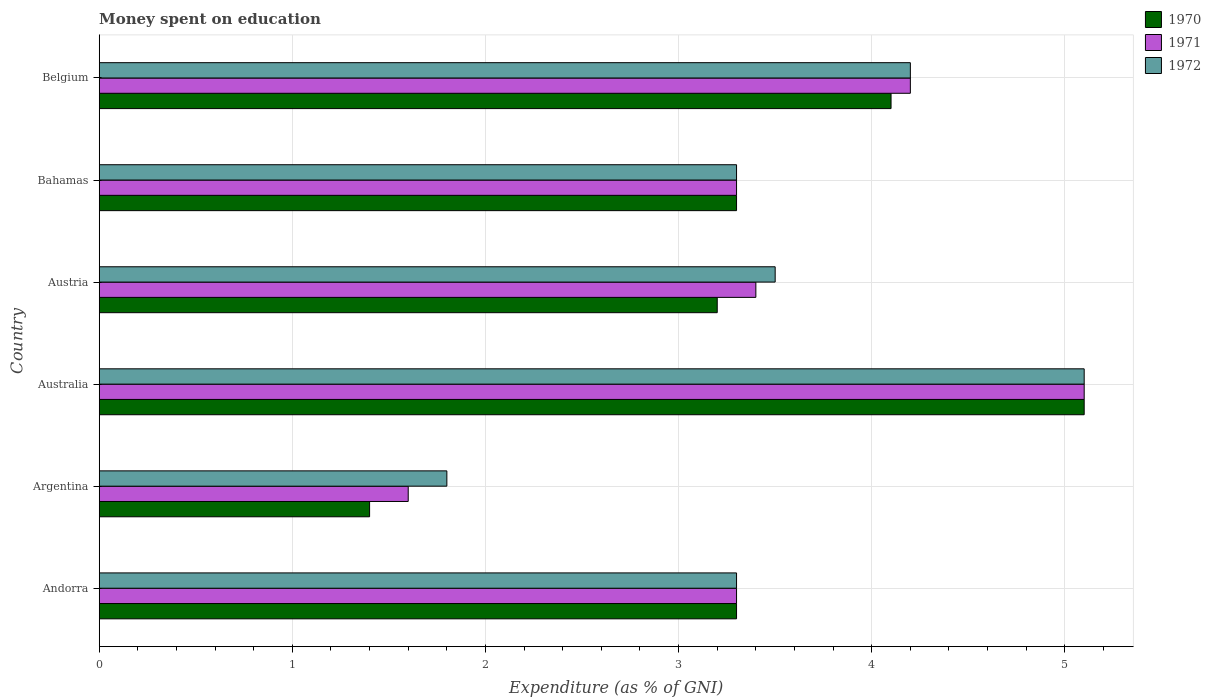How many different coloured bars are there?
Your answer should be very brief. 3. Are the number of bars per tick equal to the number of legend labels?
Your response must be concise. Yes. Are the number of bars on each tick of the Y-axis equal?
Keep it short and to the point. Yes. How many bars are there on the 6th tick from the bottom?
Provide a short and direct response. 3. Across all countries, what is the maximum amount of money spent on education in 1970?
Offer a terse response. 5.1. What is the total amount of money spent on education in 1970 in the graph?
Your response must be concise. 20.4. What is the difference between the amount of money spent on education in 1971 in Argentina and that in Austria?
Make the answer very short. -1.8. What is the difference between the amount of money spent on education in 1972 in Argentina and the amount of money spent on education in 1970 in Austria?
Offer a very short reply. -1.4. What is the average amount of money spent on education in 1972 per country?
Give a very brief answer. 3.53. What is the difference between the amount of money spent on education in 1970 and amount of money spent on education in 1971 in Andorra?
Your answer should be very brief. 0. In how many countries, is the amount of money spent on education in 1972 greater than 4.4 %?
Keep it short and to the point. 1. What is the ratio of the amount of money spent on education in 1971 in Argentina to that in Australia?
Ensure brevity in your answer.  0.31. What is the difference between the highest and the lowest amount of money spent on education in 1971?
Keep it short and to the point. 3.5. Is the sum of the amount of money spent on education in 1970 in Australia and Bahamas greater than the maximum amount of money spent on education in 1971 across all countries?
Give a very brief answer. Yes. What does the 1st bar from the bottom in Austria represents?
Your response must be concise. 1970. Is it the case that in every country, the sum of the amount of money spent on education in 1971 and amount of money spent on education in 1970 is greater than the amount of money spent on education in 1972?
Give a very brief answer. Yes. How many countries are there in the graph?
Offer a terse response. 6. Does the graph contain grids?
Keep it short and to the point. Yes. Where does the legend appear in the graph?
Offer a terse response. Top right. How many legend labels are there?
Ensure brevity in your answer.  3. What is the title of the graph?
Your answer should be very brief. Money spent on education. Does "1998" appear as one of the legend labels in the graph?
Your response must be concise. No. What is the label or title of the X-axis?
Provide a short and direct response. Expenditure (as % of GNI). What is the Expenditure (as % of GNI) of 1972 in Andorra?
Your answer should be very brief. 3.3. What is the Expenditure (as % of GNI) of 1970 in Argentina?
Provide a succinct answer. 1.4. What is the Expenditure (as % of GNI) of 1970 in Australia?
Offer a terse response. 5.1. What is the Expenditure (as % of GNI) in 1972 in Austria?
Your response must be concise. 3.5. What is the Expenditure (as % of GNI) of 1971 in Bahamas?
Provide a succinct answer. 3.3. What is the Expenditure (as % of GNI) of 1971 in Belgium?
Your answer should be very brief. 4.2. What is the Expenditure (as % of GNI) of 1972 in Belgium?
Your response must be concise. 4.2. Across all countries, what is the minimum Expenditure (as % of GNI) of 1970?
Offer a very short reply. 1.4. What is the total Expenditure (as % of GNI) in 1970 in the graph?
Your response must be concise. 20.4. What is the total Expenditure (as % of GNI) of 1971 in the graph?
Make the answer very short. 20.9. What is the total Expenditure (as % of GNI) of 1972 in the graph?
Provide a succinct answer. 21.2. What is the difference between the Expenditure (as % of GNI) in 1972 in Andorra and that in Argentina?
Make the answer very short. 1.5. What is the difference between the Expenditure (as % of GNI) in 1971 in Andorra and that in Australia?
Keep it short and to the point. -1.8. What is the difference between the Expenditure (as % of GNI) in 1970 in Andorra and that in Bahamas?
Provide a short and direct response. 0. What is the difference between the Expenditure (as % of GNI) of 1970 in Andorra and that in Belgium?
Offer a very short reply. -0.8. What is the difference between the Expenditure (as % of GNI) in 1972 in Andorra and that in Belgium?
Make the answer very short. -0.9. What is the difference between the Expenditure (as % of GNI) of 1970 in Argentina and that in Australia?
Provide a succinct answer. -3.7. What is the difference between the Expenditure (as % of GNI) of 1972 in Argentina and that in Australia?
Offer a very short reply. -3.3. What is the difference between the Expenditure (as % of GNI) of 1970 in Argentina and that in Bahamas?
Provide a short and direct response. -1.9. What is the difference between the Expenditure (as % of GNI) in 1970 in Argentina and that in Belgium?
Offer a very short reply. -2.7. What is the difference between the Expenditure (as % of GNI) of 1971 in Argentina and that in Belgium?
Offer a terse response. -2.6. What is the difference between the Expenditure (as % of GNI) of 1970 in Australia and that in Austria?
Give a very brief answer. 1.9. What is the difference between the Expenditure (as % of GNI) of 1970 in Australia and that in Bahamas?
Make the answer very short. 1.8. What is the difference between the Expenditure (as % of GNI) in 1971 in Australia and that in Bahamas?
Provide a succinct answer. 1.8. What is the difference between the Expenditure (as % of GNI) of 1972 in Australia and that in Bahamas?
Offer a terse response. 1.8. What is the difference between the Expenditure (as % of GNI) in 1970 in Australia and that in Belgium?
Provide a short and direct response. 1. What is the difference between the Expenditure (as % of GNI) in 1971 in Australia and that in Belgium?
Your response must be concise. 0.9. What is the difference between the Expenditure (as % of GNI) in 1970 in Austria and that in Bahamas?
Provide a short and direct response. -0.1. What is the difference between the Expenditure (as % of GNI) of 1970 in Austria and that in Belgium?
Offer a terse response. -0.9. What is the difference between the Expenditure (as % of GNI) in 1970 in Andorra and the Expenditure (as % of GNI) in 1971 in Argentina?
Ensure brevity in your answer.  1.7. What is the difference between the Expenditure (as % of GNI) in 1970 in Andorra and the Expenditure (as % of GNI) in 1971 in Australia?
Give a very brief answer. -1.8. What is the difference between the Expenditure (as % of GNI) in 1970 in Andorra and the Expenditure (as % of GNI) in 1972 in Australia?
Ensure brevity in your answer.  -1.8. What is the difference between the Expenditure (as % of GNI) in 1970 in Andorra and the Expenditure (as % of GNI) in 1972 in Austria?
Keep it short and to the point. -0.2. What is the difference between the Expenditure (as % of GNI) in 1971 in Andorra and the Expenditure (as % of GNI) in 1972 in Austria?
Give a very brief answer. -0.2. What is the difference between the Expenditure (as % of GNI) of 1970 in Andorra and the Expenditure (as % of GNI) of 1971 in Bahamas?
Make the answer very short. 0. What is the difference between the Expenditure (as % of GNI) of 1971 in Andorra and the Expenditure (as % of GNI) of 1972 in Belgium?
Provide a short and direct response. -0.9. What is the difference between the Expenditure (as % of GNI) in 1970 in Argentina and the Expenditure (as % of GNI) in 1971 in Australia?
Provide a short and direct response. -3.7. What is the difference between the Expenditure (as % of GNI) in 1970 in Argentina and the Expenditure (as % of GNI) in 1971 in Austria?
Give a very brief answer. -2. What is the difference between the Expenditure (as % of GNI) in 1970 in Argentina and the Expenditure (as % of GNI) in 1972 in Austria?
Offer a very short reply. -2.1. What is the difference between the Expenditure (as % of GNI) in 1971 in Argentina and the Expenditure (as % of GNI) in 1972 in Austria?
Ensure brevity in your answer.  -1.9. What is the difference between the Expenditure (as % of GNI) in 1970 in Argentina and the Expenditure (as % of GNI) in 1971 in Bahamas?
Your response must be concise. -1.9. What is the difference between the Expenditure (as % of GNI) in 1970 in Argentina and the Expenditure (as % of GNI) in 1971 in Belgium?
Make the answer very short. -2.8. What is the difference between the Expenditure (as % of GNI) in 1970 in Argentina and the Expenditure (as % of GNI) in 1972 in Belgium?
Keep it short and to the point. -2.8. What is the difference between the Expenditure (as % of GNI) of 1971 in Argentina and the Expenditure (as % of GNI) of 1972 in Belgium?
Keep it short and to the point. -2.6. What is the difference between the Expenditure (as % of GNI) in 1971 in Australia and the Expenditure (as % of GNI) in 1972 in Austria?
Your answer should be very brief. 1.6. What is the difference between the Expenditure (as % of GNI) in 1970 in Australia and the Expenditure (as % of GNI) in 1971 in Bahamas?
Keep it short and to the point. 1.8. What is the difference between the Expenditure (as % of GNI) of 1971 in Australia and the Expenditure (as % of GNI) of 1972 in Bahamas?
Provide a succinct answer. 1.8. What is the difference between the Expenditure (as % of GNI) in 1970 in Australia and the Expenditure (as % of GNI) in 1971 in Belgium?
Provide a succinct answer. 0.9. What is the difference between the Expenditure (as % of GNI) of 1970 in Australia and the Expenditure (as % of GNI) of 1972 in Belgium?
Your response must be concise. 0.9. What is the difference between the Expenditure (as % of GNI) in 1970 in Austria and the Expenditure (as % of GNI) in 1972 in Bahamas?
Make the answer very short. -0.1. What is the difference between the Expenditure (as % of GNI) of 1970 in Austria and the Expenditure (as % of GNI) of 1972 in Belgium?
Provide a short and direct response. -1. What is the difference between the Expenditure (as % of GNI) of 1971 in Austria and the Expenditure (as % of GNI) of 1972 in Belgium?
Your answer should be compact. -0.8. What is the difference between the Expenditure (as % of GNI) of 1971 in Bahamas and the Expenditure (as % of GNI) of 1972 in Belgium?
Your answer should be compact. -0.9. What is the average Expenditure (as % of GNI) in 1970 per country?
Give a very brief answer. 3.4. What is the average Expenditure (as % of GNI) of 1971 per country?
Offer a very short reply. 3.48. What is the average Expenditure (as % of GNI) in 1972 per country?
Provide a short and direct response. 3.53. What is the difference between the Expenditure (as % of GNI) in 1970 and Expenditure (as % of GNI) in 1971 in Andorra?
Provide a short and direct response. 0. What is the difference between the Expenditure (as % of GNI) in 1971 and Expenditure (as % of GNI) in 1972 in Andorra?
Give a very brief answer. 0. What is the difference between the Expenditure (as % of GNI) of 1970 and Expenditure (as % of GNI) of 1971 in Argentina?
Give a very brief answer. -0.2. What is the difference between the Expenditure (as % of GNI) of 1971 and Expenditure (as % of GNI) of 1972 in Argentina?
Offer a very short reply. -0.2. What is the difference between the Expenditure (as % of GNI) of 1970 and Expenditure (as % of GNI) of 1971 in Australia?
Make the answer very short. 0. What is the difference between the Expenditure (as % of GNI) of 1970 and Expenditure (as % of GNI) of 1972 in Austria?
Make the answer very short. -0.3. What is the difference between the Expenditure (as % of GNI) of 1971 and Expenditure (as % of GNI) of 1972 in Austria?
Make the answer very short. -0.1. What is the difference between the Expenditure (as % of GNI) in 1970 and Expenditure (as % of GNI) in 1971 in Bahamas?
Make the answer very short. 0. What is the difference between the Expenditure (as % of GNI) of 1970 and Expenditure (as % of GNI) of 1972 in Bahamas?
Your answer should be compact. 0. What is the difference between the Expenditure (as % of GNI) of 1971 and Expenditure (as % of GNI) of 1972 in Bahamas?
Provide a succinct answer. 0. What is the difference between the Expenditure (as % of GNI) in 1970 and Expenditure (as % of GNI) in 1971 in Belgium?
Offer a very short reply. -0.1. What is the difference between the Expenditure (as % of GNI) of 1971 and Expenditure (as % of GNI) of 1972 in Belgium?
Ensure brevity in your answer.  0. What is the ratio of the Expenditure (as % of GNI) in 1970 in Andorra to that in Argentina?
Your answer should be compact. 2.36. What is the ratio of the Expenditure (as % of GNI) of 1971 in Andorra to that in Argentina?
Keep it short and to the point. 2.06. What is the ratio of the Expenditure (as % of GNI) of 1972 in Andorra to that in Argentina?
Keep it short and to the point. 1.83. What is the ratio of the Expenditure (as % of GNI) of 1970 in Andorra to that in Australia?
Your answer should be compact. 0.65. What is the ratio of the Expenditure (as % of GNI) of 1971 in Andorra to that in Australia?
Provide a short and direct response. 0.65. What is the ratio of the Expenditure (as % of GNI) of 1972 in Andorra to that in Australia?
Give a very brief answer. 0.65. What is the ratio of the Expenditure (as % of GNI) in 1970 in Andorra to that in Austria?
Ensure brevity in your answer.  1.03. What is the ratio of the Expenditure (as % of GNI) of 1971 in Andorra to that in Austria?
Your answer should be very brief. 0.97. What is the ratio of the Expenditure (as % of GNI) in 1972 in Andorra to that in Austria?
Provide a short and direct response. 0.94. What is the ratio of the Expenditure (as % of GNI) of 1970 in Andorra to that in Bahamas?
Your response must be concise. 1. What is the ratio of the Expenditure (as % of GNI) in 1971 in Andorra to that in Bahamas?
Your response must be concise. 1. What is the ratio of the Expenditure (as % of GNI) of 1972 in Andorra to that in Bahamas?
Give a very brief answer. 1. What is the ratio of the Expenditure (as % of GNI) of 1970 in Andorra to that in Belgium?
Offer a very short reply. 0.8. What is the ratio of the Expenditure (as % of GNI) of 1971 in Andorra to that in Belgium?
Offer a very short reply. 0.79. What is the ratio of the Expenditure (as % of GNI) of 1972 in Andorra to that in Belgium?
Offer a terse response. 0.79. What is the ratio of the Expenditure (as % of GNI) in 1970 in Argentina to that in Australia?
Keep it short and to the point. 0.27. What is the ratio of the Expenditure (as % of GNI) of 1971 in Argentina to that in Australia?
Your answer should be compact. 0.31. What is the ratio of the Expenditure (as % of GNI) of 1972 in Argentina to that in Australia?
Offer a very short reply. 0.35. What is the ratio of the Expenditure (as % of GNI) in 1970 in Argentina to that in Austria?
Provide a succinct answer. 0.44. What is the ratio of the Expenditure (as % of GNI) in 1971 in Argentina to that in Austria?
Your answer should be very brief. 0.47. What is the ratio of the Expenditure (as % of GNI) in 1972 in Argentina to that in Austria?
Provide a succinct answer. 0.51. What is the ratio of the Expenditure (as % of GNI) in 1970 in Argentina to that in Bahamas?
Provide a succinct answer. 0.42. What is the ratio of the Expenditure (as % of GNI) in 1971 in Argentina to that in Bahamas?
Make the answer very short. 0.48. What is the ratio of the Expenditure (as % of GNI) in 1972 in Argentina to that in Bahamas?
Ensure brevity in your answer.  0.55. What is the ratio of the Expenditure (as % of GNI) of 1970 in Argentina to that in Belgium?
Give a very brief answer. 0.34. What is the ratio of the Expenditure (as % of GNI) of 1971 in Argentina to that in Belgium?
Provide a succinct answer. 0.38. What is the ratio of the Expenditure (as % of GNI) of 1972 in Argentina to that in Belgium?
Keep it short and to the point. 0.43. What is the ratio of the Expenditure (as % of GNI) in 1970 in Australia to that in Austria?
Your answer should be compact. 1.59. What is the ratio of the Expenditure (as % of GNI) in 1972 in Australia to that in Austria?
Provide a succinct answer. 1.46. What is the ratio of the Expenditure (as % of GNI) of 1970 in Australia to that in Bahamas?
Give a very brief answer. 1.55. What is the ratio of the Expenditure (as % of GNI) in 1971 in Australia to that in Bahamas?
Keep it short and to the point. 1.55. What is the ratio of the Expenditure (as % of GNI) of 1972 in Australia to that in Bahamas?
Your answer should be very brief. 1.55. What is the ratio of the Expenditure (as % of GNI) in 1970 in Australia to that in Belgium?
Offer a very short reply. 1.24. What is the ratio of the Expenditure (as % of GNI) in 1971 in Australia to that in Belgium?
Offer a very short reply. 1.21. What is the ratio of the Expenditure (as % of GNI) of 1972 in Australia to that in Belgium?
Keep it short and to the point. 1.21. What is the ratio of the Expenditure (as % of GNI) of 1970 in Austria to that in Bahamas?
Ensure brevity in your answer.  0.97. What is the ratio of the Expenditure (as % of GNI) in 1971 in Austria to that in Bahamas?
Offer a terse response. 1.03. What is the ratio of the Expenditure (as % of GNI) in 1972 in Austria to that in Bahamas?
Give a very brief answer. 1.06. What is the ratio of the Expenditure (as % of GNI) of 1970 in Austria to that in Belgium?
Keep it short and to the point. 0.78. What is the ratio of the Expenditure (as % of GNI) in 1971 in Austria to that in Belgium?
Ensure brevity in your answer.  0.81. What is the ratio of the Expenditure (as % of GNI) in 1972 in Austria to that in Belgium?
Offer a very short reply. 0.83. What is the ratio of the Expenditure (as % of GNI) of 1970 in Bahamas to that in Belgium?
Your answer should be compact. 0.8. What is the ratio of the Expenditure (as % of GNI) of 1971 in Bahamas to that in Belgium?
Provide a short and direct response. 0.79. What is the ratio of the Expenditure (as % of GNI) of 1972 in Bahamas to that in Belgium?
Keep it short and to the point. 0.79. What is the difference between the highest and the second highest Expenditure (as % of GNI) in 1971?
Offer a very short reply. 0.9. What is the difference between the highest and the lowest Expenditure (as % of GNI) of 1971?
Your answer should be compact. 3.5. 